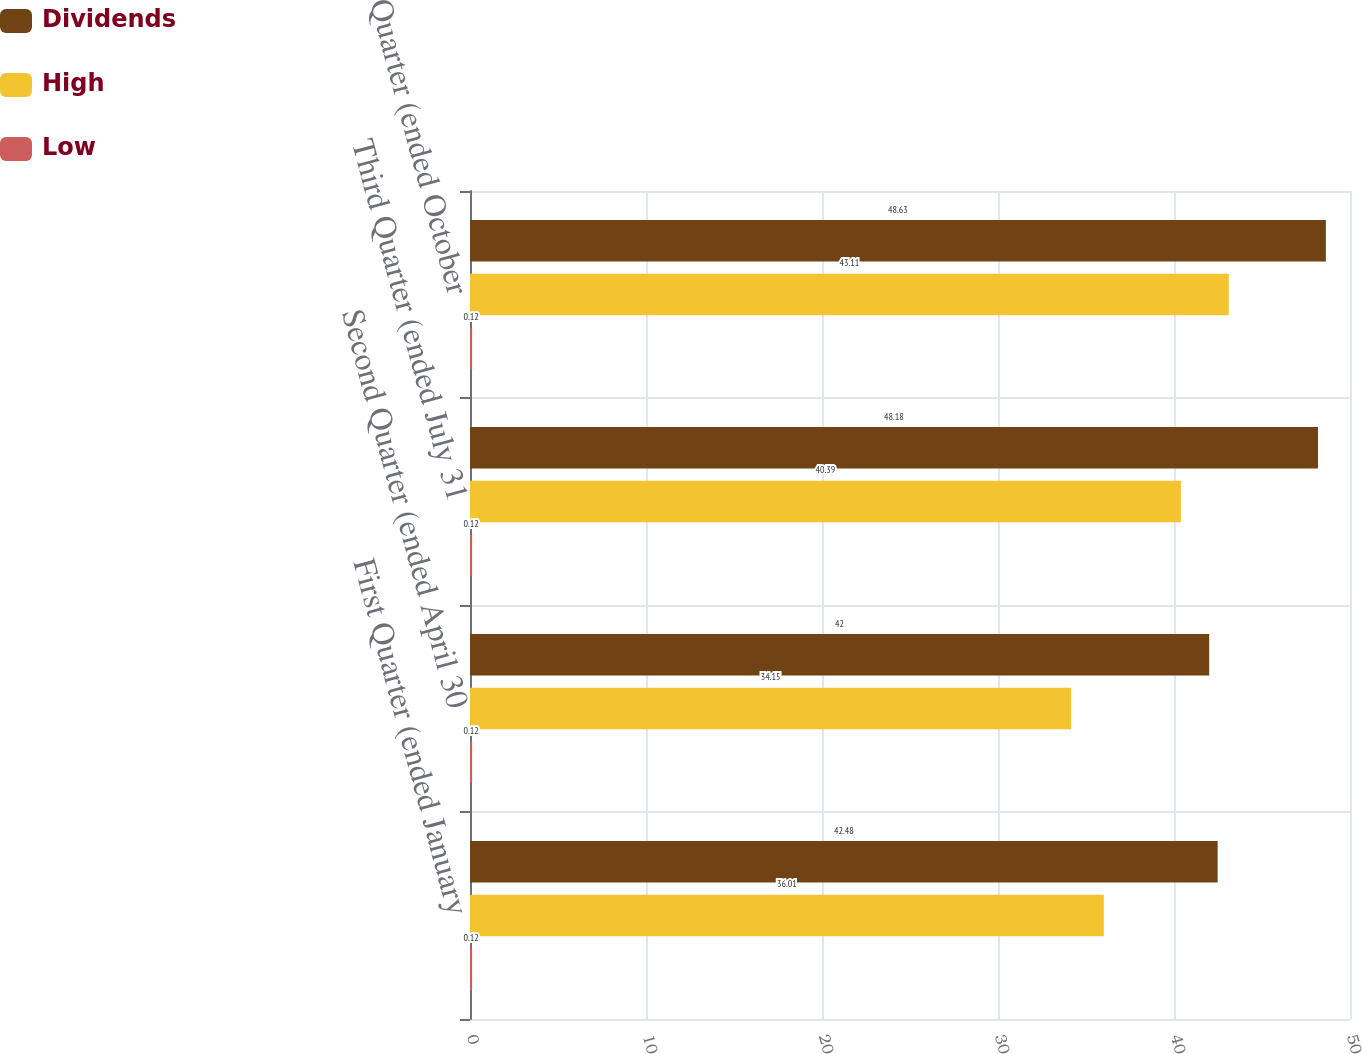Convert chart. <chart><loc_0><loc_0><loc_500><loc_500><stacked_bar_chart><ecel><fcel>First Quarter (ended January<fcel>Second Quarter (ended April 30<fcel>Third Quarter (ended July 31<fcel>Fourth Quarter (ended October<nl><fcel>Dividends<fcel>42.48<fcel>42<fcel>48.18<fcel>48.63<nl><fcel>High<fcel>36.01<fcel>34.15<fcel>40.39<fcel>43.11<nl><fcel>Low<fcel>0.12<fcel>0.12<fcel>0.12<fcel>0.12<nl></chart> 